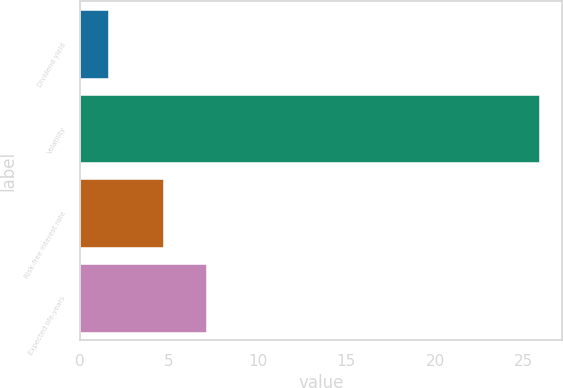<chart> <loc_0><loc_0><loc_500><loc_500><bar_chart><fcel>Dividend yield<fcel>Volatility<fcel>Risk-free interest rate<fcel>Expected life-years<nl><fcel>1.61<fcel>25.86<fcel>4.7<fcel>7.12<nl></chart> 